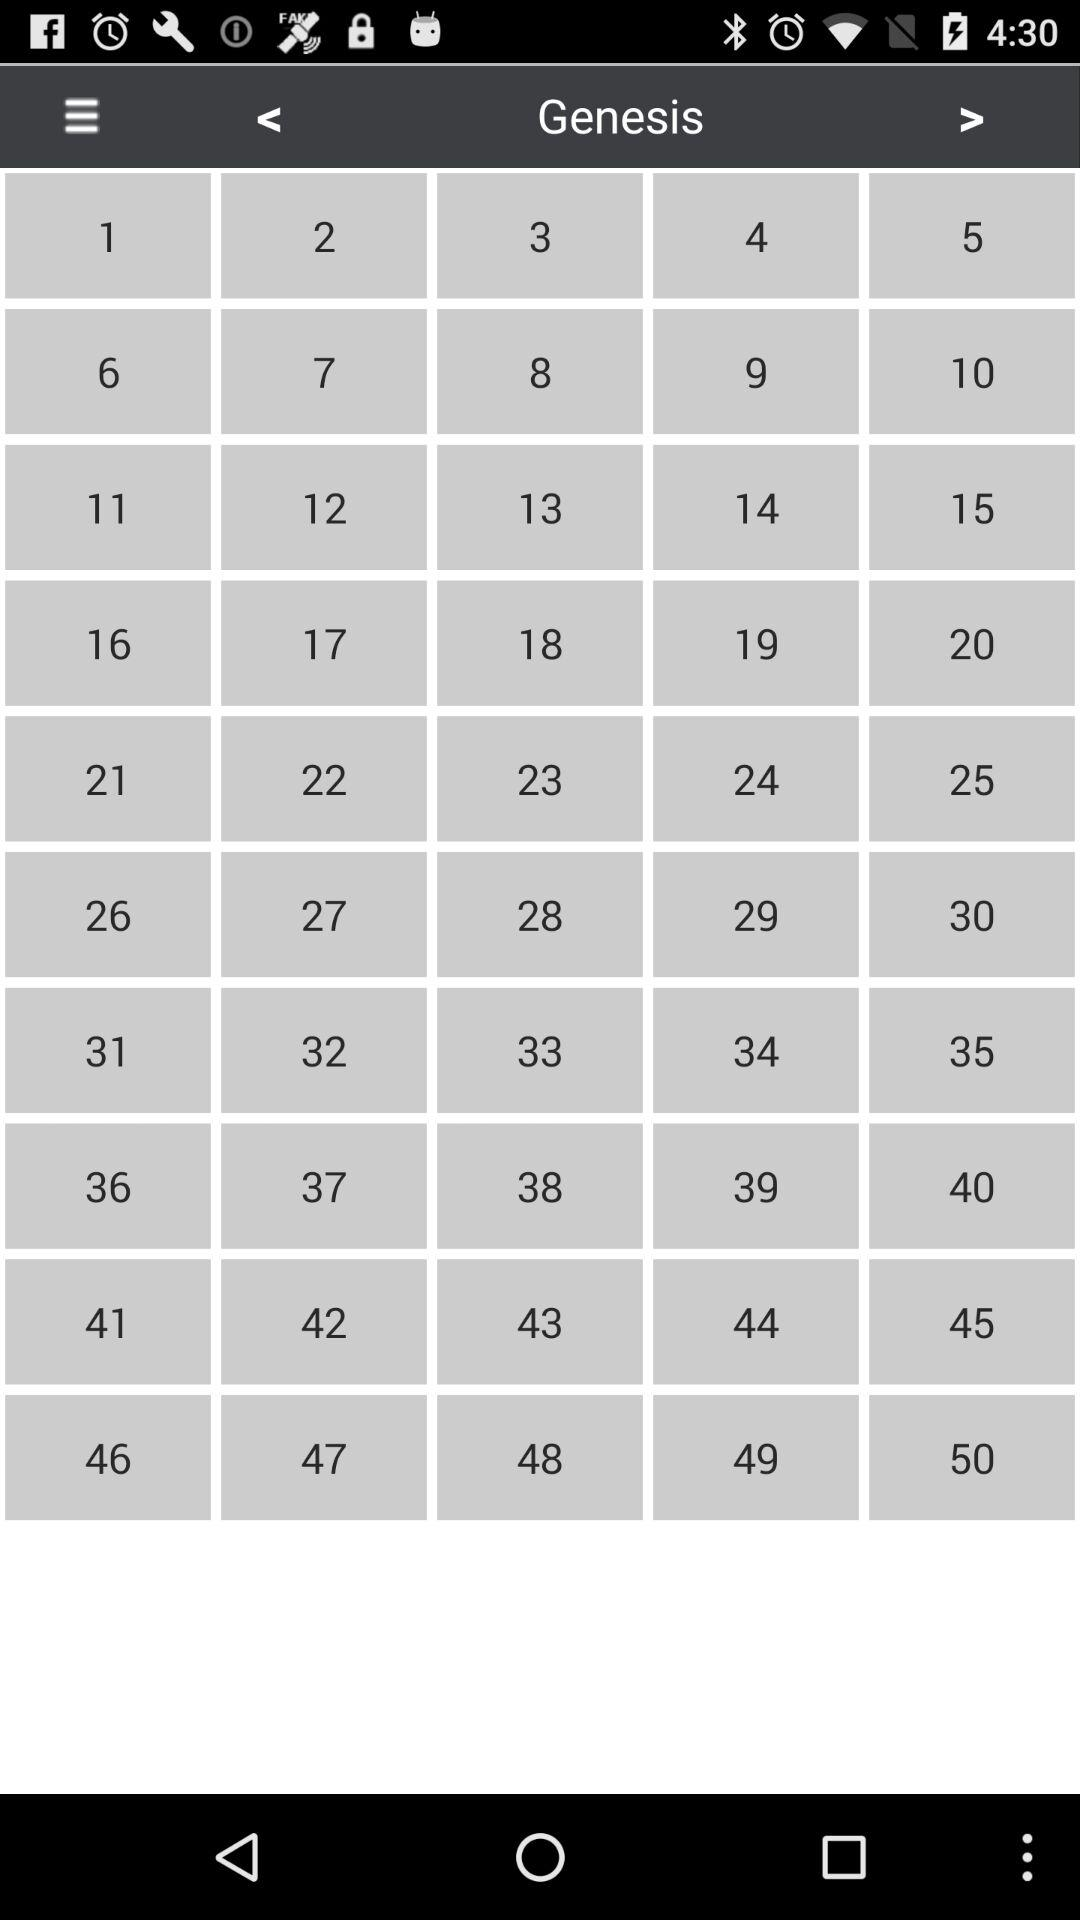How many text elements are there on the screen?
Answer the question using a single word or phrase. 50 